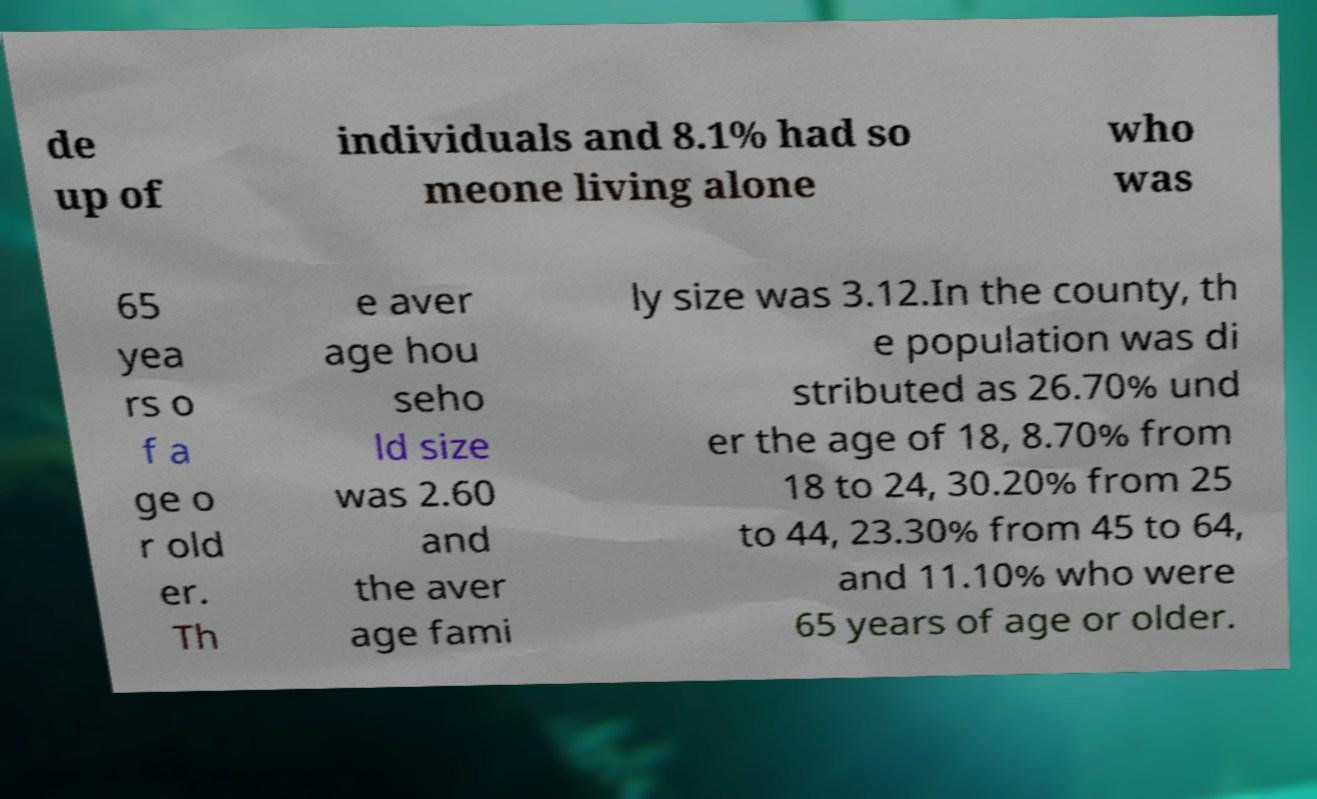What messages or text are displayed in this image? I need them in a readable, typed format. de up of individuals and 8.1% had so meone living alone who was 65 yea rs o f a ge o r old er. Th e aver age hou seho ld size was 2.60 and the aver age fami ly size was 3.12.In the county, th e population was di stributed as 26.70% und er the age of 18, 8.70% from 18 to 24, 30.20% from 25 to 44, 23.30% from 45 to 64, and 11.10% who were 65 years of age or older. 